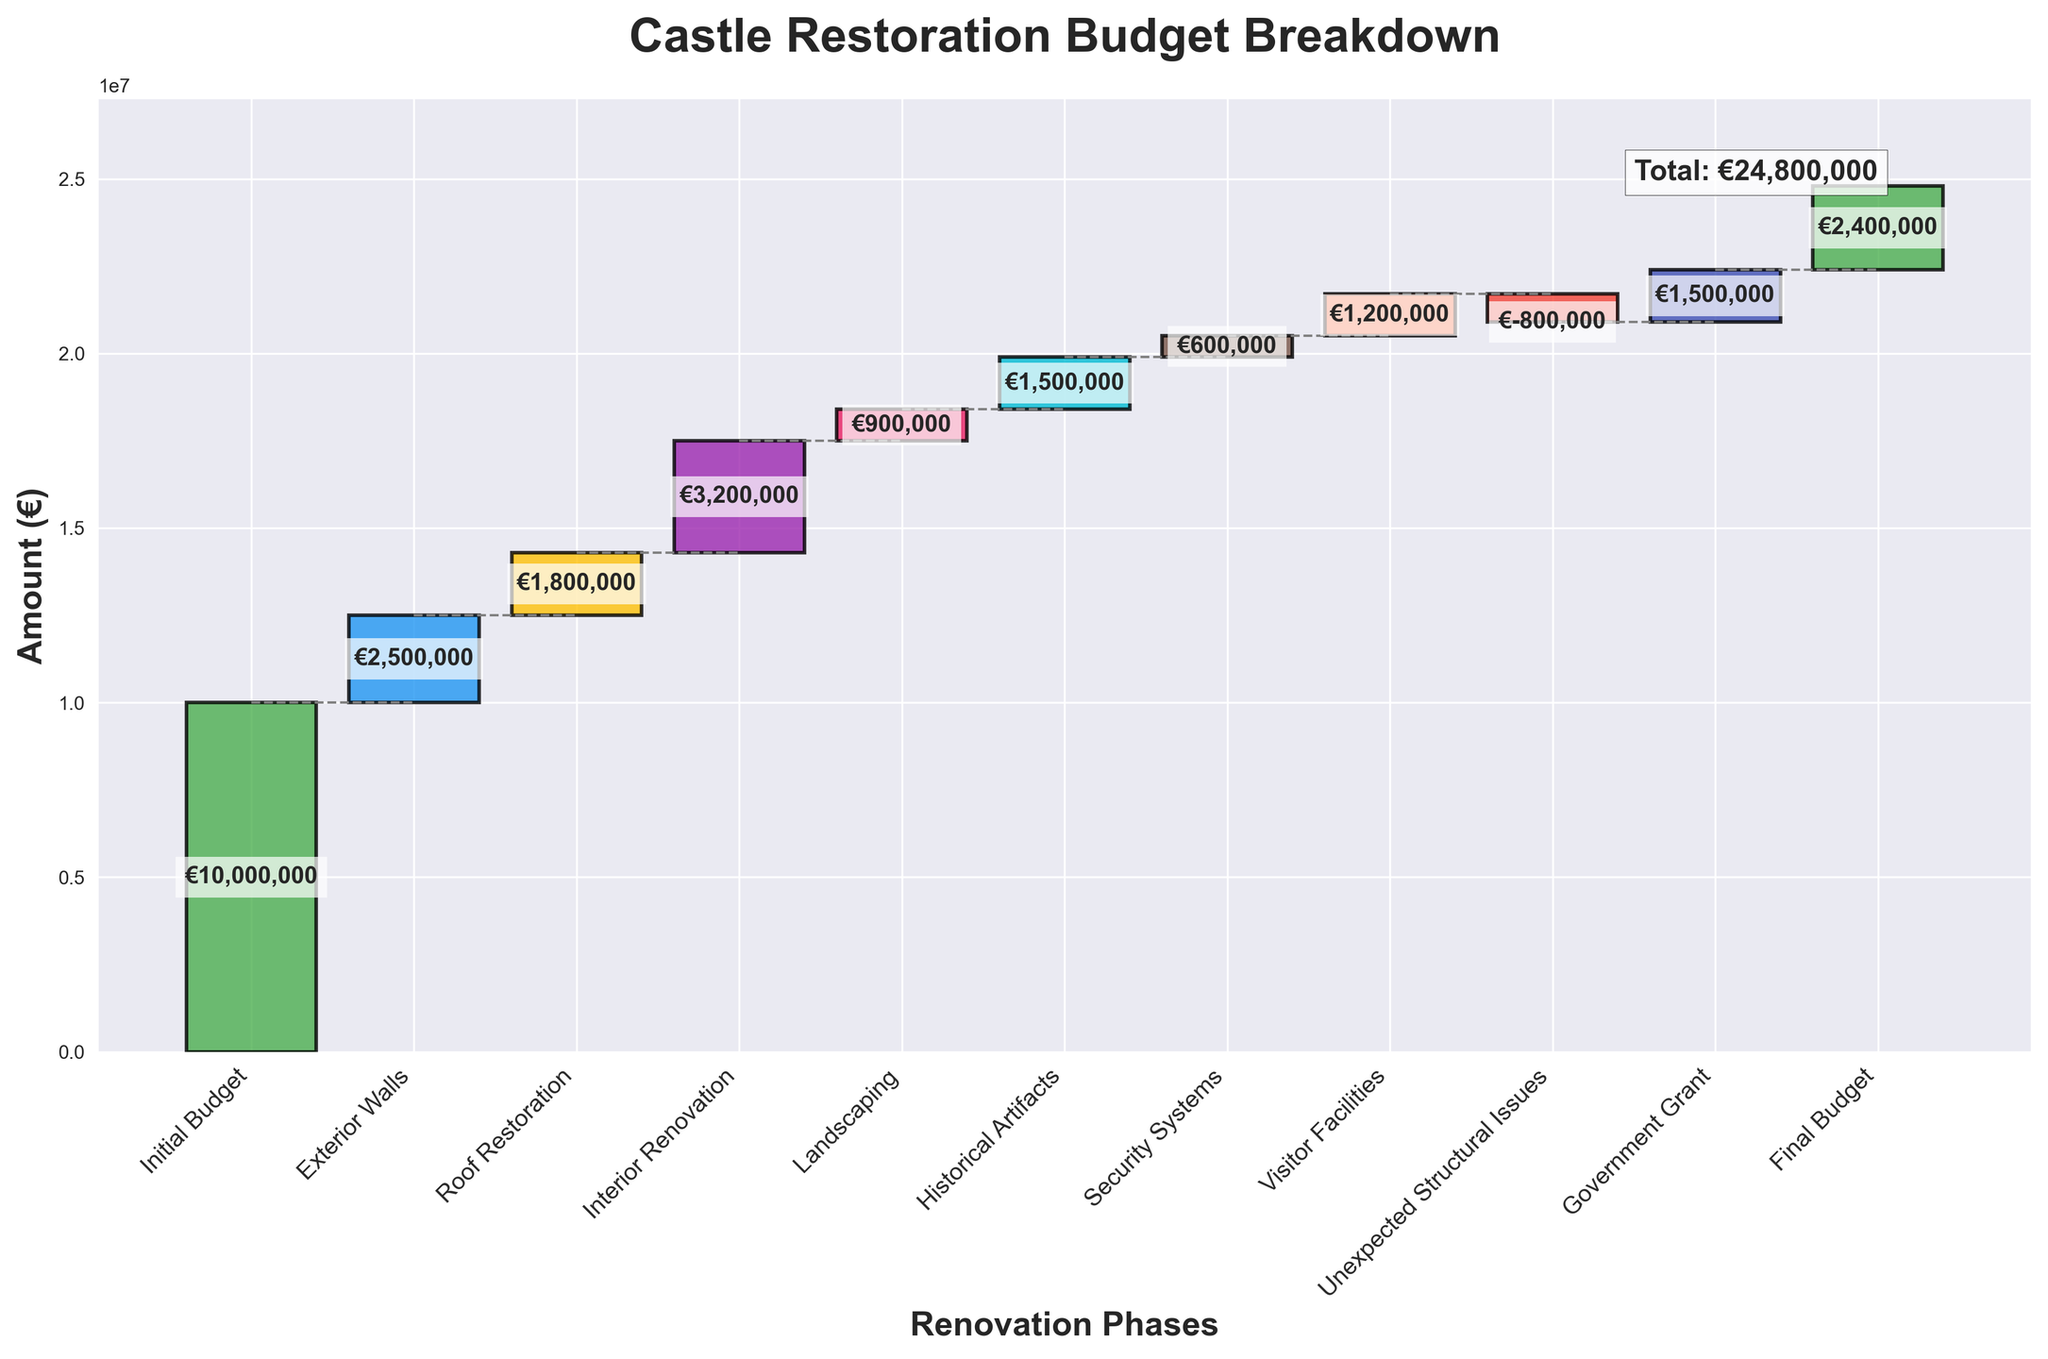What is the title of the chart? The title of the chart is located at the top and provides an overview of what the chart is about.
Answer: Castle Restoration Budget Breakdown How many renovation phases are represented in the chart? The chart has one bar for each renovation phase, and you can count them from start to end.
Answer: 10 What is the initial budget for the castle restoration? The initial budget is the first category in the waterfall chart, depicted as the first bar.
Answer: €10,000,000 Which renovation phase incurs the highest cost? By observing the heights of all the bars (positive values), the tallest bar represents the highest cost phase.
Answer: Interior Renovation (€3,200,000) What is the total cost for the Exterior Walls and Roof Restoration combined? Add the values for Exterior Walls (€2,500,000) and Roof Restoration (€1,800,000).
Answer: €4,300,000 What is the amount gained from the Government Grant? The Government Grant is represented as a positive bar among the renovation phases and its value is written on the bar.
Answer: €1,500,000 What is the total cost incurred due to Unexpected Structural Issues, Landscaping, and Security Systems? Add the values for Unexpected Structural Issues (€-800,000), Landscaping (€900,000), and Security Systems (€600,000).
Answer: €700,000 Which phase has a negative impact on the budget? A negative phase will be represented by a downward (negative) bar in the chart with a negative value.
Answer: Unexpected Structural Issues (€-800,000) What is the difference between the final budget and the initial budget? Subtract the final budget (€2,400,000) from the initial budget (€10,000,000).
Answer: €7,600,000 How do the costs of Visitor Facilities and Historical Artifacts compare? Compare the values of Visitor Facilities (€1,200,000) and Historical Artifacts (€1,500,000).
Answer: Historical Artifacts costs €300,000 more than Visitor Facilities 